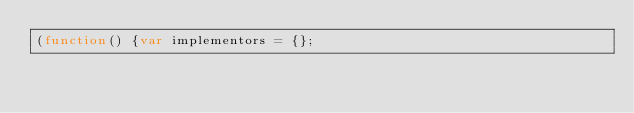<code> <loc_0><loc_0><loc_500><loc_500><_JavaScript_>(function() {var implementors = {};</code> 